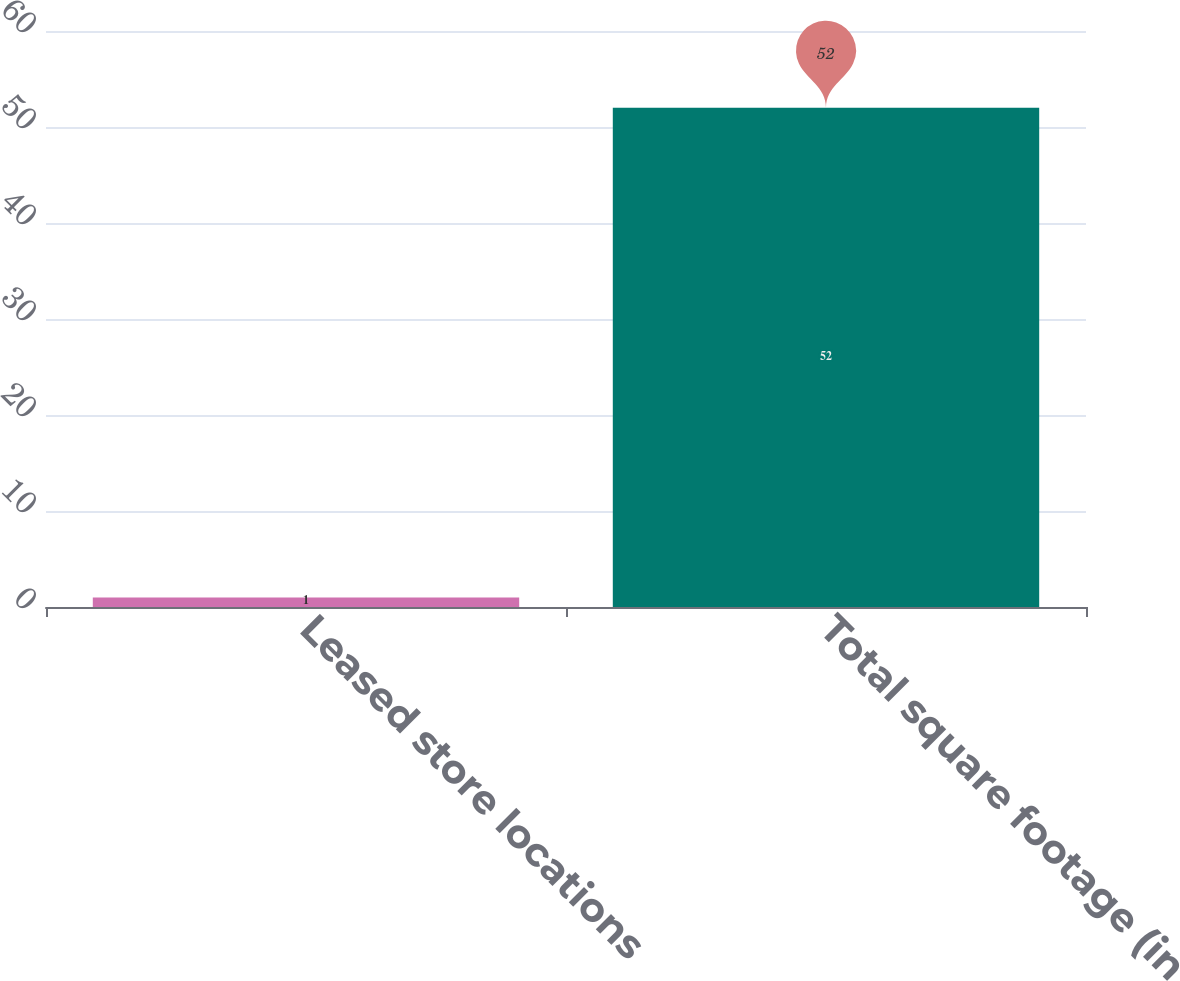Convert chart. <chart><loc_0><loc_0><loc_500><loc_500><bar_chart><fcel>Leased store locations<fcel>Total square footage (in<nl><fcel>1<fcel>52<nl></chart> 